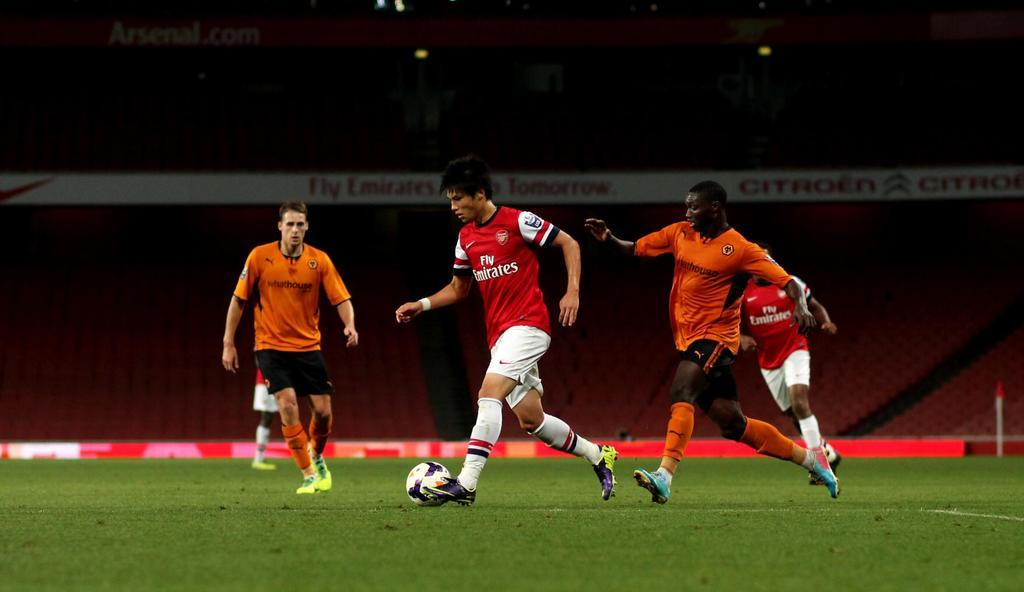Who or what can be seen in the image? There are people in the image. What is the position of the people in the image? The people are standing on the ground. What object is present in the image along with the people? There is a football present in the image. What type of vacation is the doll planning in the image? There is no doll or vacation mentioned in the image; it features people and a football. 